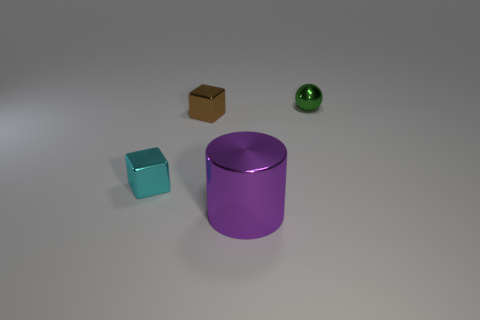The small cyan thing that is the same material as the green sphere is what shape?
Provide a short and direct response. Cube. Are there any other things that have the same shape as the green thing?
Keep it short and to the point. No. There is a tiny cyan metal cube; how many purple metal objects are behind it?
Offer a terse response. 0. Is there a small cylinder?
Ensure brevity in your answer.  No. The metal cube in front of the metal block to the right of the thing that is on the left side of the small brown metal thing is what color?
Your answer should be very brief. Cyan. There is a small metal object behind the brown shiny cube; is there a tiny metallic object in front of it?
Keep it short and to the point. Yes. There is a thing to the right of the large purple object; does it have the same color as the tiny metal cube that is right of the cyan shiny object?
Keep it short and to the point. No. How many green metallic spheres have the same size as the purple thing?
Ensure brevity in your answer.  0. Do the metal block in front of the brown metal block and the purple object have the same size?
Your answer should be compact. No. The big purple thing has what shape?
Your response must be concise. Cylinder. 